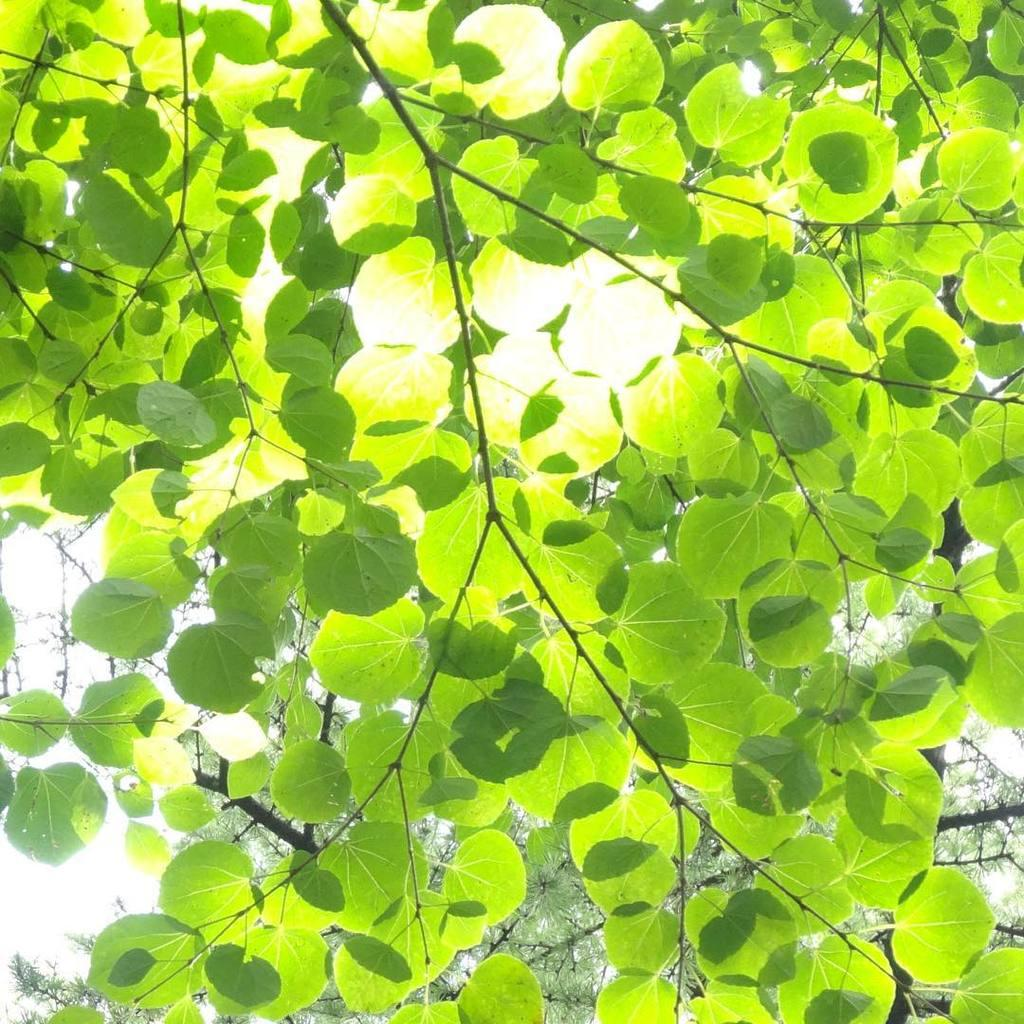What type of vegetation can be seen in the image? There are trees in the image. What part of the trees is visible in the image? There are leaves in the image. What type of laborer can be seen working on the trees in the image? There is no laborer present in the image; it only shows trees and leaves. How many times does the person in the image kick the tree? There is no person present in the image, and therefore no kicking can be observed. 